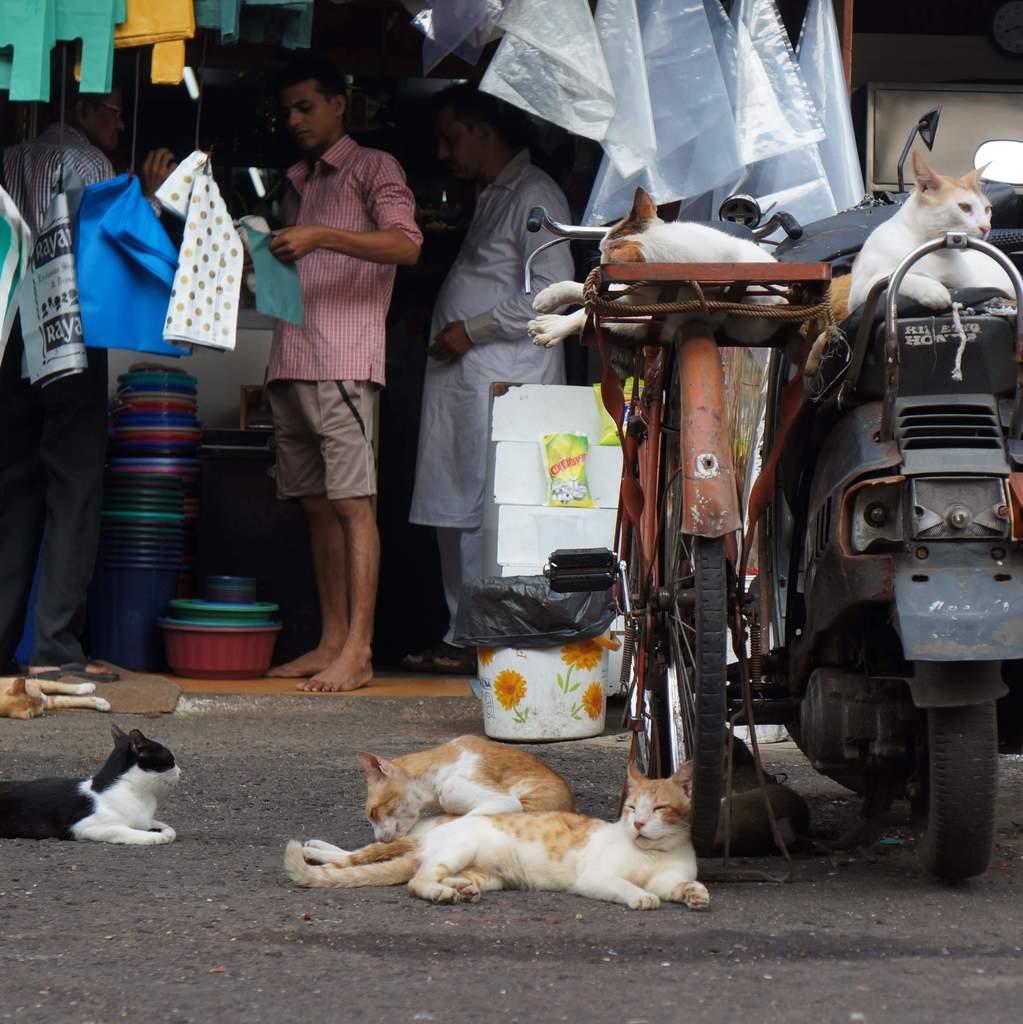Can you describe this image briefly? In this image we can see people standing. There are polythene covers. There is a bicycle and vehicle. There are cats. At the bottom of the image there is road. 